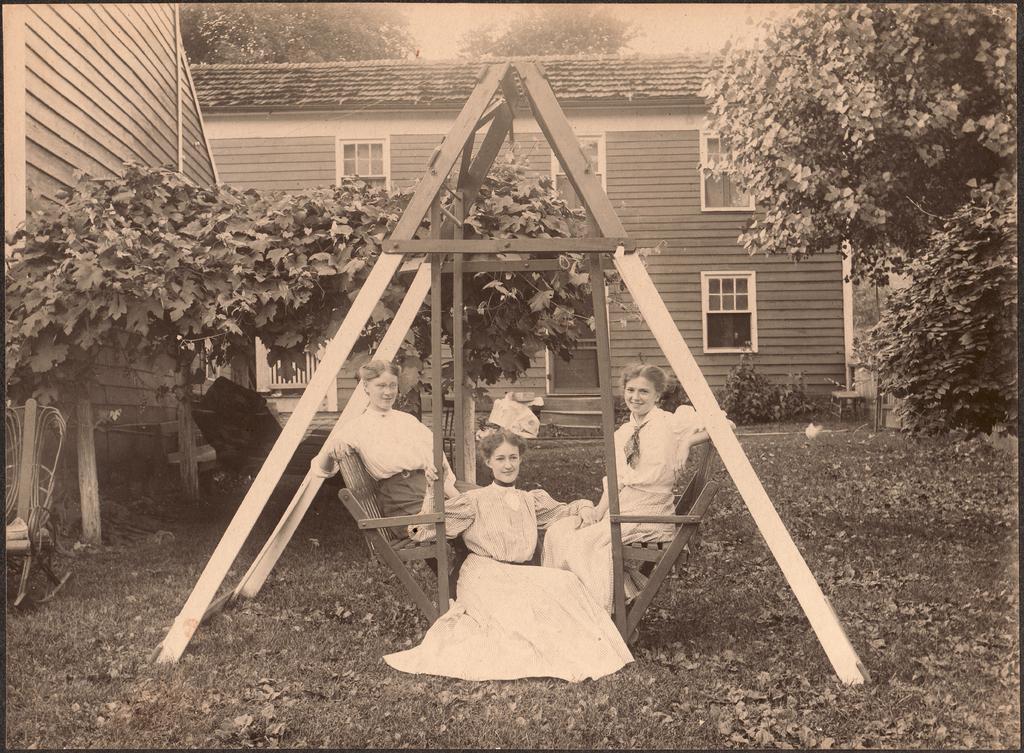Could you give a brief overview of what you see in this image? In the center of the image we can see a stand and there are people sitting. In the background there is a building and we can see trees. On the left there is a chair. 